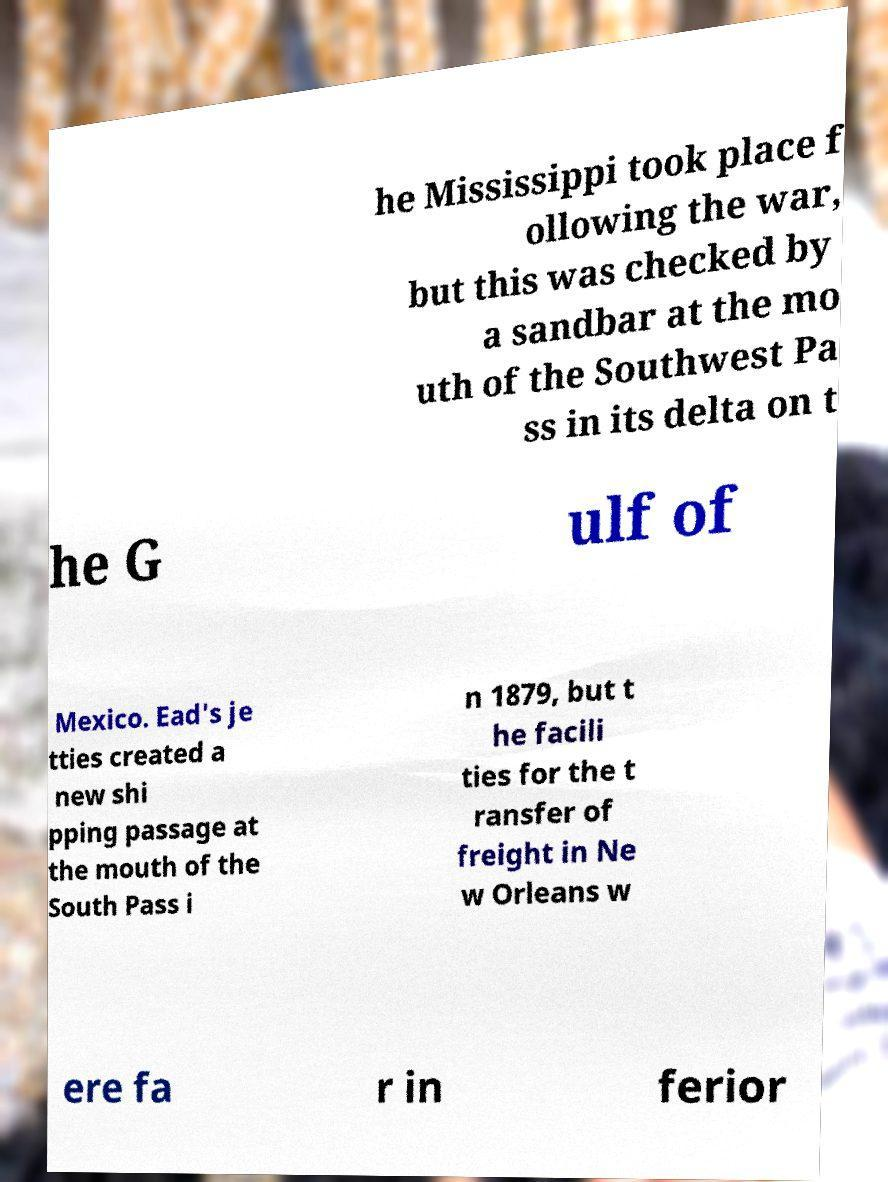Can you read and provide the text displayed in the image?This photo seems to have some interesting text. Can you extract and type it out for me? he Mississippi took place f ollowing the war, but this was checked by a sandbar at the mo uth of the Southwest Pa ss in its delta on t he G ulf of Mexico. Ead's je tties created a new shi pping passage at the mouth of the South Pass i n 1879, but t he facili ties for the t ransfer of freight in Ne w Orleans w ere fa r in ferior 